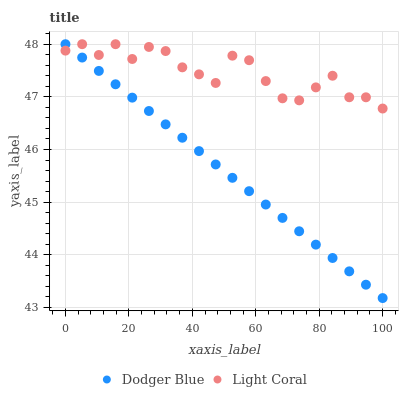Does Dodger Blue have the minimum area under the curve?
Answer yes or no. Yes. Does Light Coral have the maximum area under the curve?
Answer yes or no. Yes. Does Dodger Blue have the maximum area under the curve?
Answer yes or no. No. Is Dodger Blue the smoothest?
Answer yes or no. Yes. Is Light Coral the roughest?
Answer yes or no. Yes. Is Dodger Blue the roughest?
Answer yes or no. No. Does Dodger Blue have the lowest value?
Answer yes or no. Yes. Does Dodger Blue have the highest value?
Answer yes or no. Yes. Does Light Coral intersect Dodger Blue?
Answer yes or no. Yes. Is Light Coral less than Dodger Blue?
Answer yes or no. No. Is Light Coral greater than Dodger Blue?
Answer yes or no. No. 